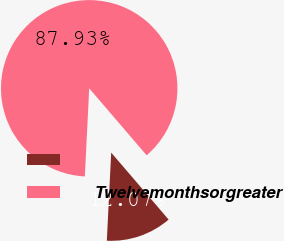Convert chart to OTSL. <chart><loc_0><loc_0><loc_500><loc_500><pie_chart><ecel><fcel>Twelvemonthsorgreater<nl><fcel>12.07%<fcel>87.93%<nl></chart> 